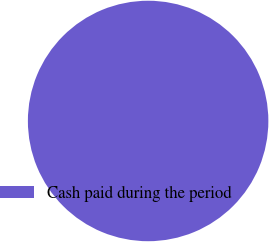Convert chart to OTSL. <chart><loc_0><loc_0><loc_500><loc_500><pie_chart><fcel>Cash paid during the period<nl><fcel>100.0%<nl></chart> 